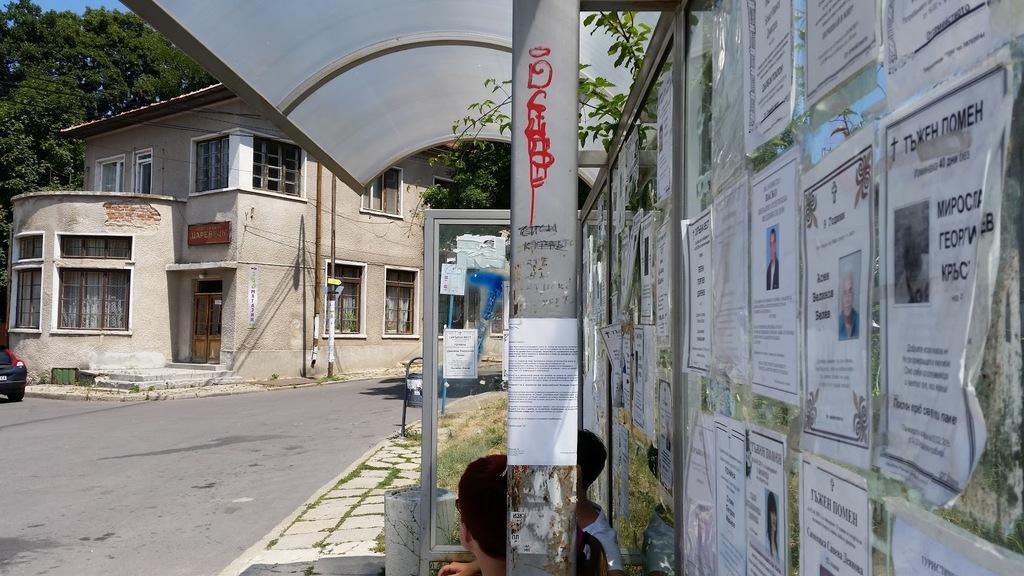Can you describe this image briefly? In this picture we can observe a building. There is a pole and we can observe some papers stuck to the glass wall on the right side. There are children sitting here. We can observe a road. In the background there are trees. 